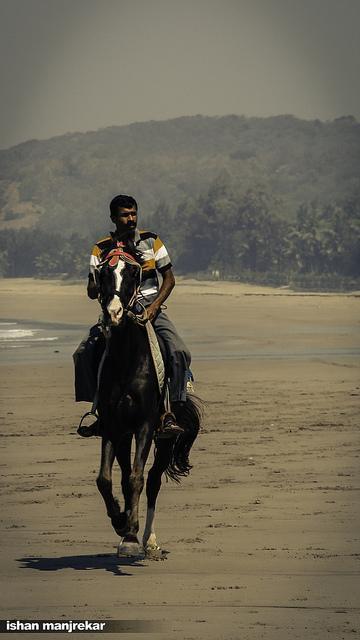How many people can you see?
Give a very brief answer. 1. 